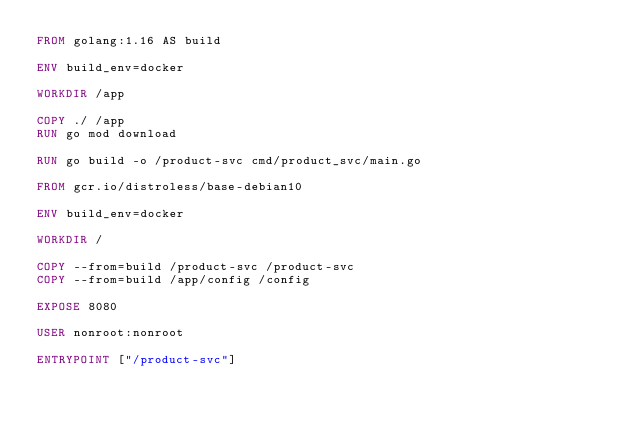Convert code to text. <code><loc_0><loc_0><loc_500><loc_500><_Dockerfile_>FROM golang:1.16 AS build

ENV build_env=docker

WORKDIR /app

COPY ./ /app
RUN go mod download

RUN go build -o /product-svc cmd/product_svc/main.go

FROM gcr.io/distroless/base-debian10

ENV build_env=docker

WORKDIR /

COPY --from=build /product-svc /product-svc
COPY --from=build /app/config /config

EXPOSE 8080

USER nonroot:nonroot

ENTRYPOINT ["/product-svc"]</code> 